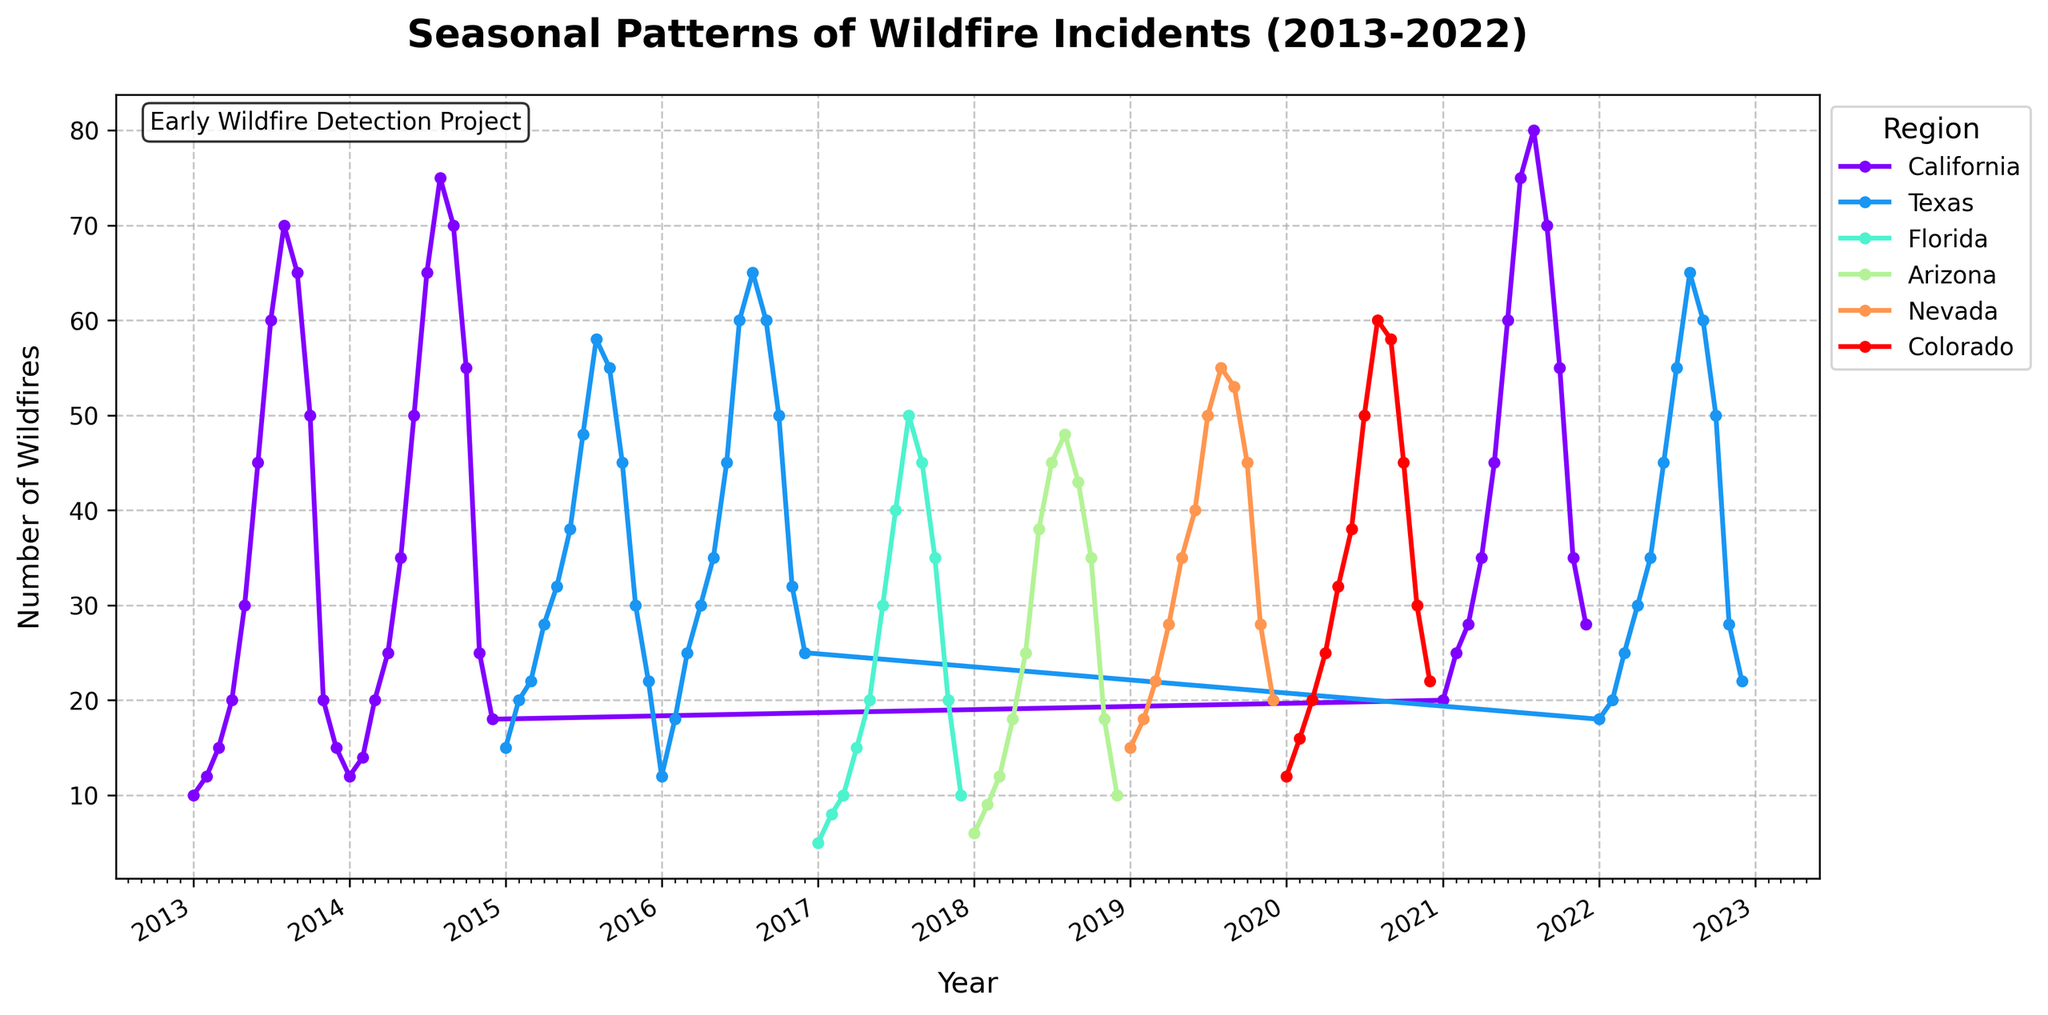How many regions are represented in the plot? The legend in the plot specifies different regions. By counting the unique entries in the legend, we can determine the number of regions represented.
Answer: 6 What is the highest number of wildfires recorded in a single month for California across all years? By observing the plot and the California data line, the peak value corresponds to the highest number of wildfires recorded in a single month.
Answer: 80 Which region had the lowest number of wildfires in January 2017? Refer to the specific data point for January 2017 in the plot and compare the values for different regions.
Answer: Florida Comparing July 2013 and July 2021, did the number of wildfires increase or decrease in California? Trace the lines for California for the mentioned months and compare the data points visually.
Answer: Increase What is the average number of wildfires in June for all regions combined across all years? Add up the data points for June for all the regions from the plot and divide by the number of years (2013 to 2022, i.e., 10 years of data for each region).
Answer: 42.5 Which month typically shows the highest number of wildfires in Nevada? By following the line for Nevada across the years, identify the month which consistently displays the highest peaks.
Answer: August Between January and December of 2018 in Arizona, how does the number of wildfires change? Analyze the trend line for Arizona specifically from January to December 2018.
Answer: Increase then decrease Which region had the highest variability in wildfire incidents over the decade? By observing the plot, note which region has the widest fluctuations in terms of the highest and lowest data points, indicating high variability.
Answer: California By how much did the number of wildfires in March 2020 exceed those in March 2015 in Colorado? Compare the vertical positions of the data points for March 2020 and March 2015 in Colorado and find the difference.
Answer: 0 What pattern, if any, is observed regarding the seasonality of wildfires across the regions? Look for recurring trends in the data lines corresponding to different regions over the months and years to identify if there's a seasonal pattern.
Answer: Peaks in Summer/Fall 